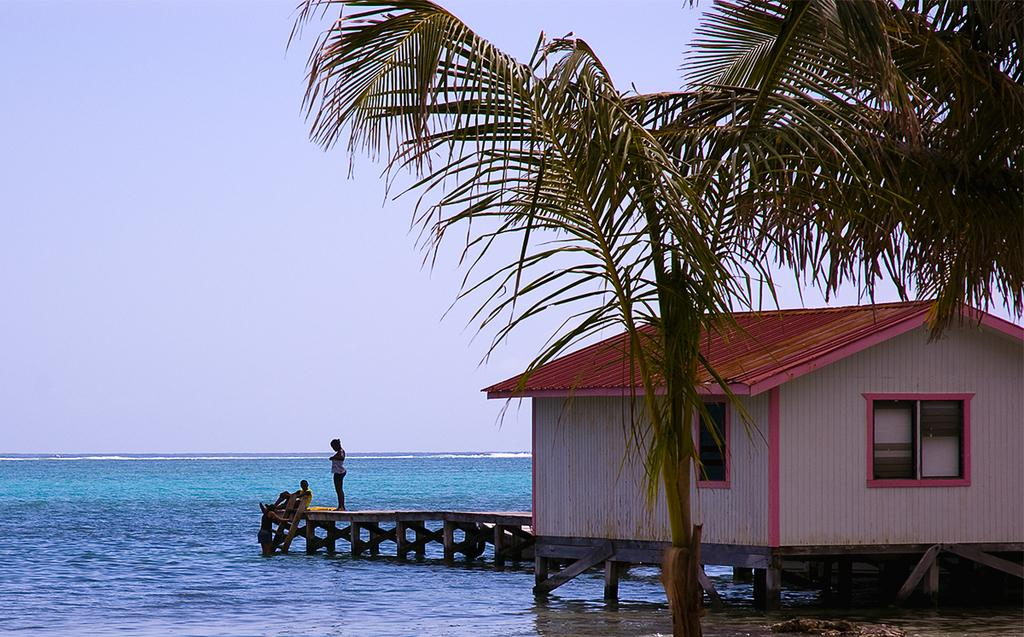What type of house is in the image? There is a wooden house in the image. What features can be seen on the wooden house? The wooden house has windows. What other natural elements are present in the image? There are trees and water visible in the image. What structure can be seen crossing the water? There is a wooden bridge in the image. How many people are in the image? There are two people in the image. What is visible at the top of the image? The sky is visible at the top of the image. What is the purpose of the snow in the image? There is no snow present in the image, so it cannot serve any purpose. 